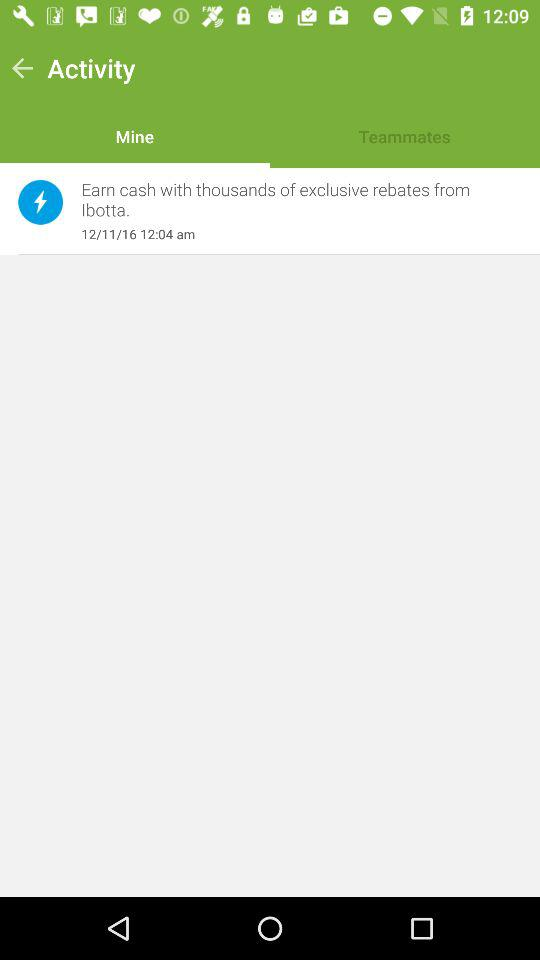Who are the teammates?
When the provided information is insufficient, respond with <no answer>. <no answer> 